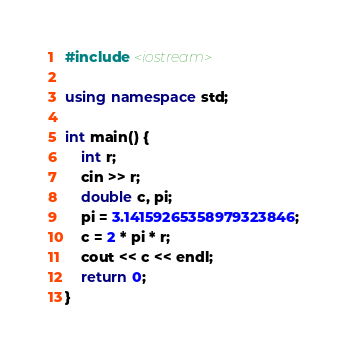<code> <loc_0><loc_0><loc_500><loc_500><_C++_>#include <iostream>

using namespace std;

int main() {
    int r;
    cin >> r;
    double c, pi;
    pi = 3.14159265358979323846;
    c = 2 * pi * r;
    cout << c << endl;
    return 0;
}</code> 